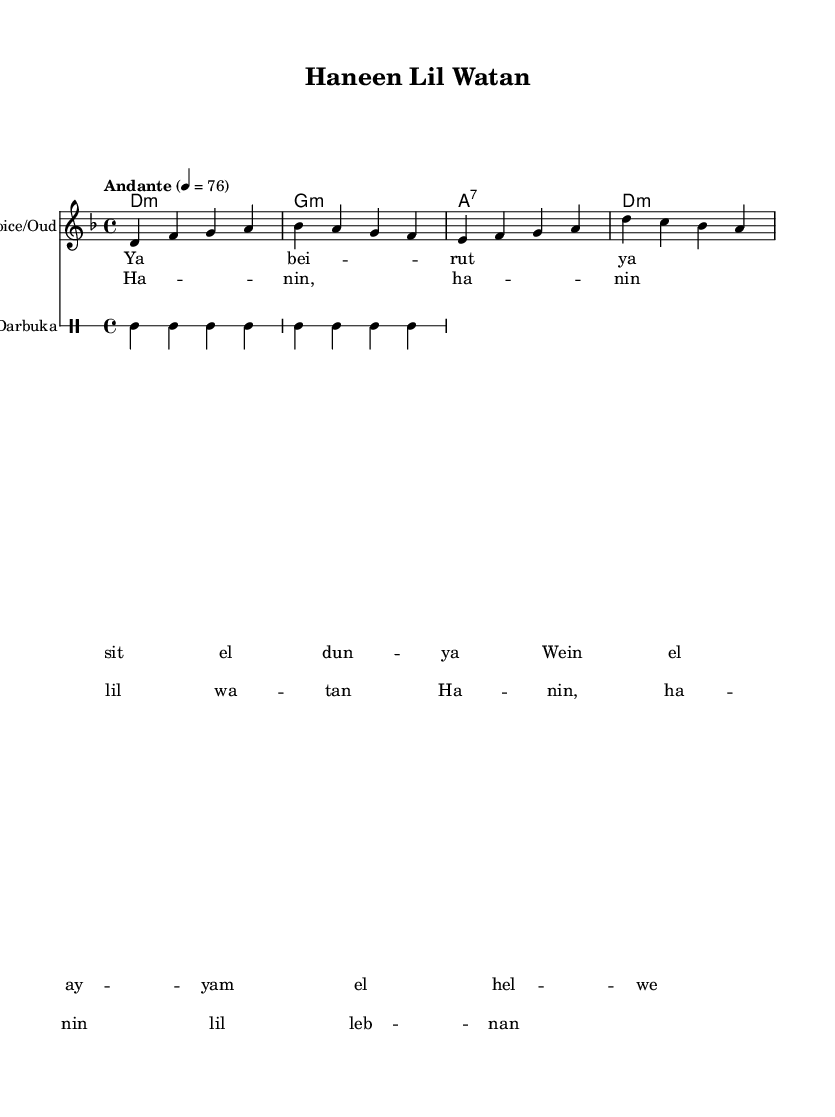What is the key signature of this music? The key signature is D minor, which indicates that it has one flat (B flat). This can be determined by looking at the key signature indicated at the beginning of the staff.
Answer: D minor What is the time signature of this music? The time signature is 4/4, which can be seen at the beginning of the piece. This means there are four beats in each measure.
Answer: 4/4 What is the tempo marking of the piece? The tempo marking is "Andante", which indicates a moderate pace. This is shown at the start of the score and suggests how quickly the music should be played.
Answer: Andante How many measures are in the verse section? The verse section consists of four measures, as indicated by the notation in the sheet music where the lyrics are aligned with the melody.
Answer: Four What instrument is indicated alongside the voice? The instrument indicated is "Oud," which is typically used in Lebanese folk music. This is noted at the beginning of the staff for the melody.
Answer: Oud What type of chords are used in the harmonies? The chords used are minor and a seventh chord; specifically, D minor, G minor, and A seventh chords are present as noted in the chord mode at the beginning of the harmonies section.
Answer: Minor and seventh What does the chorus lyric "Hanin lil Watan" translate to in English? The lyric "Hanin lil Watan" translates to "Longing for the homeland." This reflects a theme of nostalgia which is common in Lebanese folk songs about emigration.
Answer: Longing for the homeland 